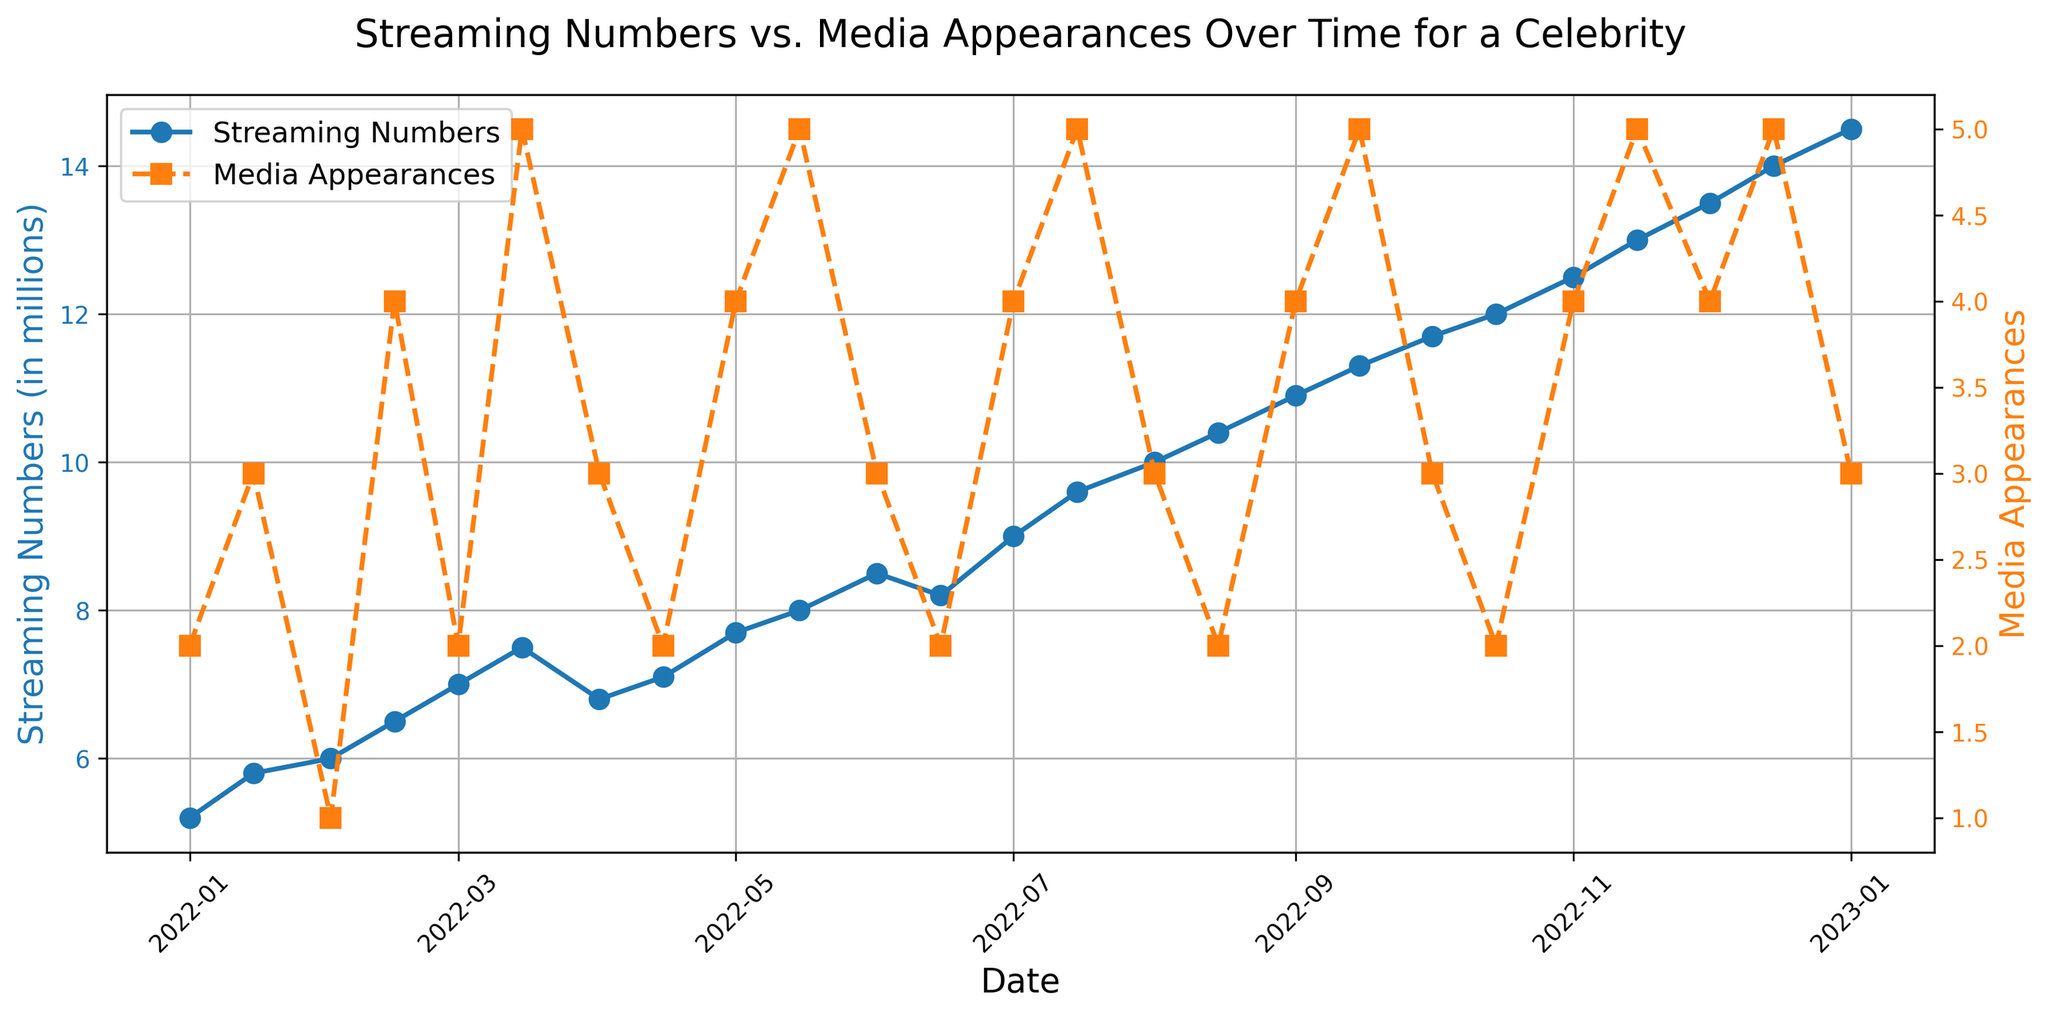What is the highest recorded streaming number within the given time frame? By visually inspecting the blue line representing streaming numbers, we can see the peak value at the end of the chart. The highest recorded streaming number is around 14.5 million on 2023-01-01.
Answer: 14.5 million Which date shows a peak in media appearances and what is the corresponding number of streaming numbers on that same date? Identifying the peak of the orange dashed line shows the highest media appearances on 2022-12-15, with five appearances. The corresponding value for the streaming numbers (blue line) at this date is around 14.0 million.
Answer: 2022-12-15, 14.0 million What is the difference in streaming numbers between the start and the end of the year 2022? The streaming numbers at the start of the year (2022-01-01) are approximately 5.2 million. By the end of the year (2022-12-15), the streaming numbers are around 14.0 million. The difference is calculated as 14.0 - 5.2 = 8.8 million.
Answer: 8.8 million On which date did the number of media appearances rapidly increase, and what was the change in streaming numbers around this period? On examining the orange dashed line, there's a noticeable increase in media appearances from one to four between 2022-02-01 and 2022-02-15. Concurrently, the streaming numbers (blue line) increased from around 6.0 million to 6.5 million.
Answer: 2022-02-15, 0.5 million increase How do the streaming numbers and media appearances correlate between 2022-05-15 and 2022-07-01? Between these dates, the number of media appearances increased from 5 on 2022-05-15 to 4 on 2022-07-01, whereas streaming numbers rose from 8.0 million to 9.0 million. This indicates a positive correlation where both metrics increased during this time period.
Answer: Positive correlation, increase in both What is the average number of media appearances per month in the second half of 2022? There are six months in the second half of the year (July to December). Summing the media appearance values for these months gives: 4 (Jul 01) + 5 (Jul 15) + 3 (Aug 01) + 2 (Aug 15) + 4 (Sep 01) + 5 (Sep 15) + 3 (Oct 01) + 2 (Oct 15) + 4 (Nov 01) + 5 (Nov 15) + 4 (Dec 01) + 5 (Dec 15) = 46. We then divide by 6 months: 46 / 6 = 7.67.
Answer: 7.67 How many times did streaming numbers decrease despite an increase in media appearances up to 2023-01-01, and when were these occurrences? By analyzing both lines, we need to spot places where the orange line rises but the blue line falls. Instances include 2022-04-01 (reduces to 6.8 million despite 3 media appearances). Thus, it occurred once.
Answer: Once, on 2022-04-01 On what dates did media appearances maintain the same number across two consecutive periods, and what happens to the streaming numbers on these dates? By following the orange dashed line, we note dates where it remains flat. One example is from 2022-08-15 to 2022-09-01 with the same number of media appearances (2). The streaming numbers increased from 10.4 million to 10.9 million during this period. Another instance falls between 2022-10-15 to 2022-11-01 with 2 media appearances. Streaming numbers rose from 12.0 million to 12.5 million.
Answer: 2022-08-15 to 2022-09-01, increase; 2022-10-15 to 2022-11-01, increase 